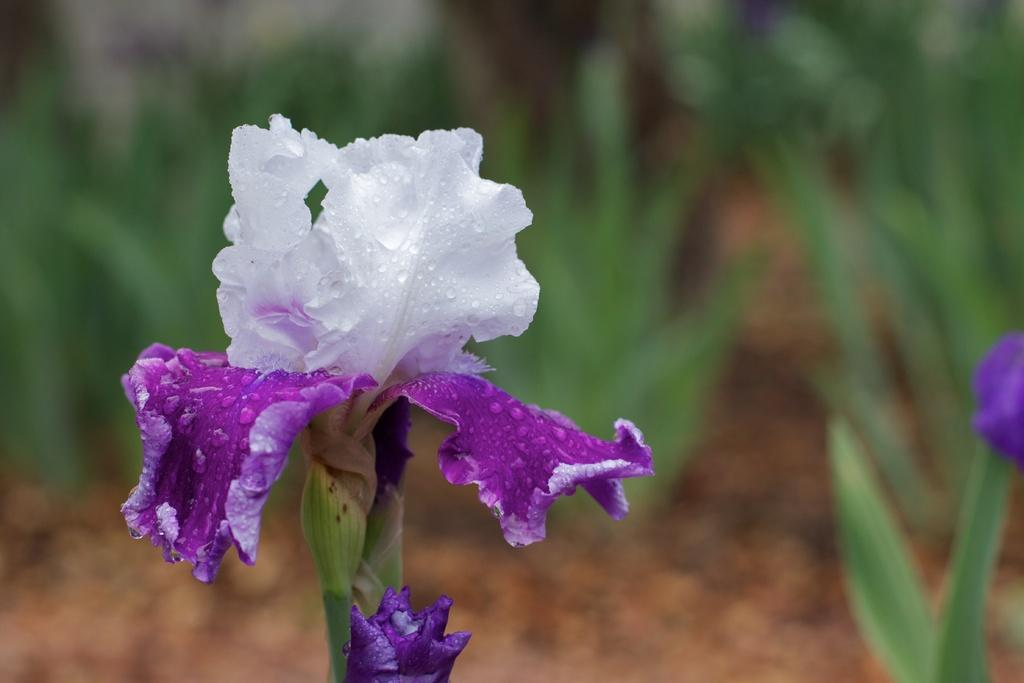What type of living organisms can be seen in the image? There are flowers and plants visible in the image. Can you describe the background of the image? The background of the image is blurred. What type of list can be seen hanging from the curtain in the image? There is no list or curtain present in the image. What joke is being told by the flowers in the image? There is no joke being told by the flowers in the image. 